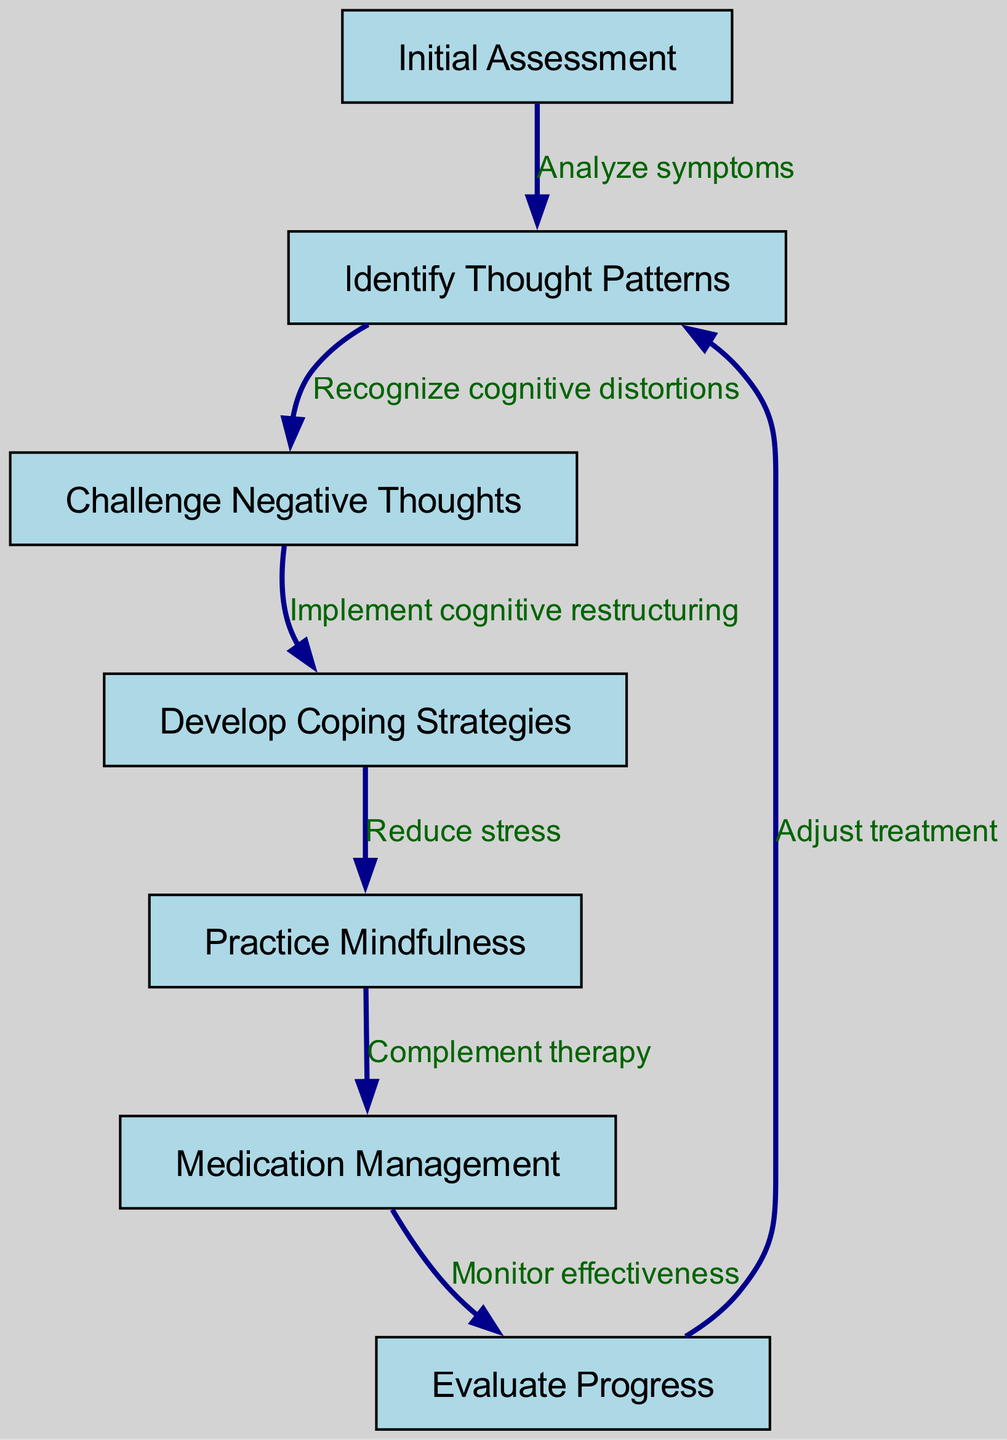What is the first step in the CBT process? The first step in the CBT process, as indicated by the first node in the diagram, is "Initial Assessment."
Answer: Initial Assessment How many nodes are present in the diagram? By counting the nodes listed in the data, there are 7 nodes in total.
Answer: 7 What is the relationship between "Identify Thought Patterns" and "Challenge Negative Thoughts"? The relationship is described by the edge connecting these two nodes, which states "Recognize cognitive distortions."
Answer: Recognize cognitive distortions What precedes "Evaluate Progress" in the CBT process? Before "Evaluate Progress," the process involves "Medication Management," as shown by the direct connection from node six to node seven.
Answer: Medication Management What strategy is used to help reduce stress in the CBT process? The block diagram indicates that "Develop Coping Strategies" is used to help reduce stress, as it connects to "Practice Mindfulness."
Answer: Develop Coping Strategies Which node leads to "Medication Management"? The node that leads to "Medication Management" is "Practice Mindfulness," as indicated by the directed edge from node five to node six.
Answer: Practice Mindfulness What action is taken after evaluating progress in the CBT process? After evaluating progress, the next step is to "Adjust treatment," which loops back to "Identify Thought Patterns," highlighting an iterative review.
Answer: Adjust treatment How does "Challenge Negative Thoughts" support the overall process? "Challenge Negative Thoughts" supports the process by being a critical step in implementing cognitive restructuring, thus guiding clients toward healthier thought patterns.
Answer: Implement cognitive restructuring What color are the nodes in the diagram? The nodes in the diagram are filled with a light blue color, as specified in the attributes for the node style.
Answer: Light blue 